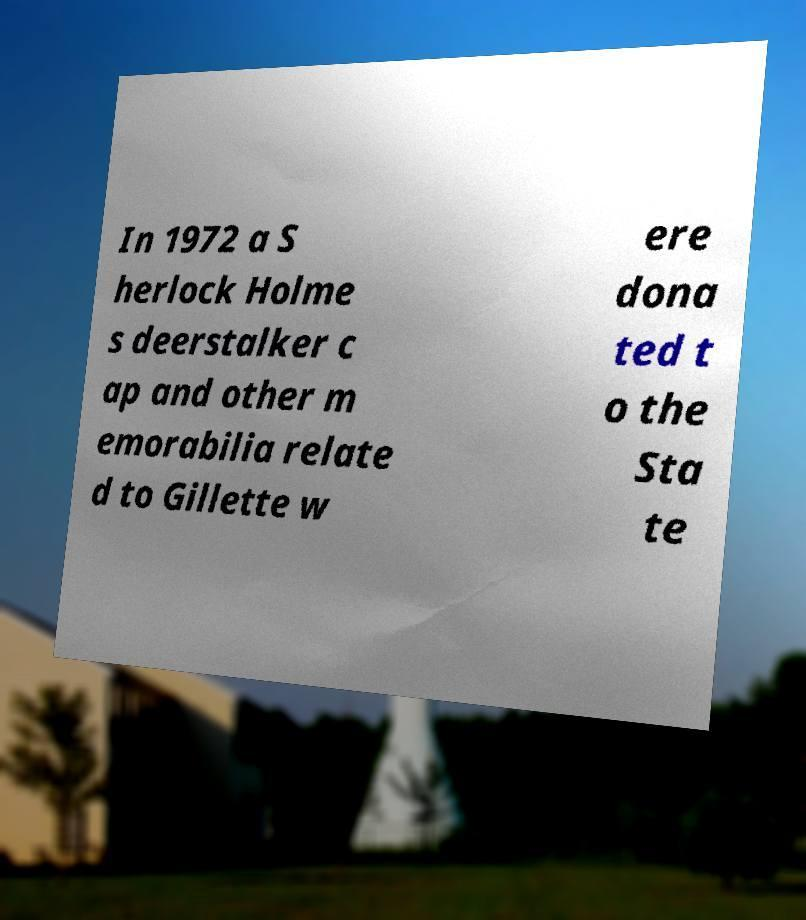Please read and relay the text visible in this image. What does it say? In 1972 a S herlock Holme s deerstalker c ap and other m emorabilia relate d to Gillette w ere dona ted t o the Sta te 